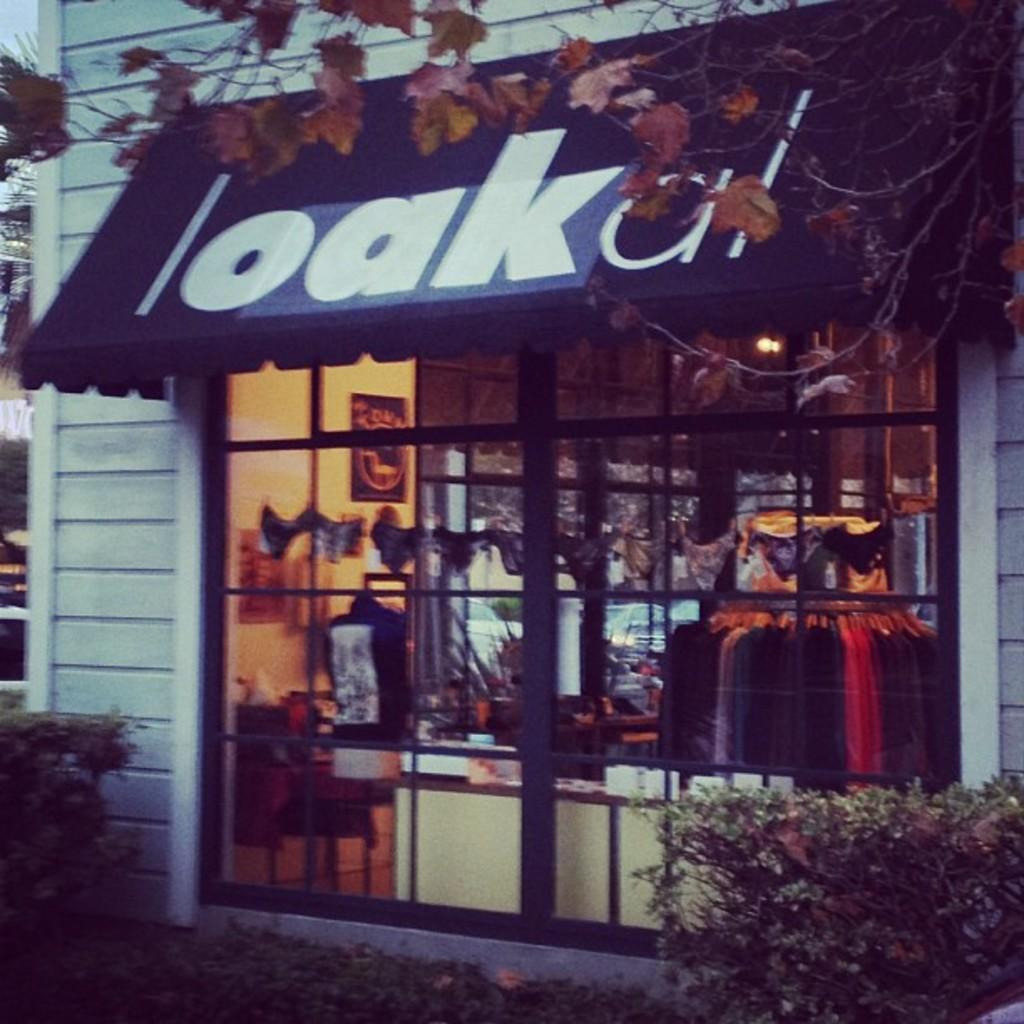What type of establishment is shown in the image? There is a store in the image. What can be seen in the background of the image? Branches, leaves, and plants are visible in the image. What items are visible inside the store? Clothes are visible in the image. What architectural feature is present in the store? There is a glass window in the image. What type of lighting is present in the store? Lights are present in the image. What decorative element is present on the wall of the store? There is a poster on the wall in the image. What object in the image has writing on it? Something is written on a black object in the image. What type of cheese is being polished on the crack in the image? There is no cheese or crack present in the image. 